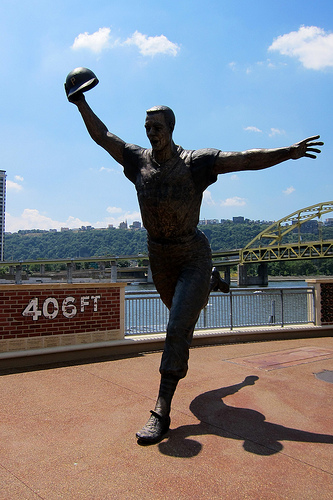<image>
Is the statue on the floor? Yes. Looking at the image, I can see the statue is positioned on top of the floor, with the floor providing support. Is the cap behind the sky? Yes. From this viewpoint, the cap is positioned behind the sky, with the sky partially or fully occluding the cap. Is there a statue in front of the bridge? Yes. The statue is positioned in front of the bridge, appearing closer to the camera viewpoint. 